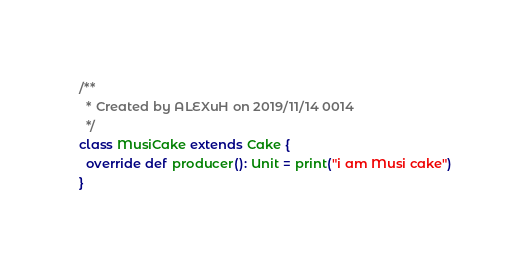<code> <loc_0><loc_0><loc_500><loc_500><_Scala_>
/**
  * Created by ALEXuH on 2019/11/14 0014
  */
class MusiCake extends Cake {
  override def producer(): Unit = print("i am Musi cake")
}
</code> 